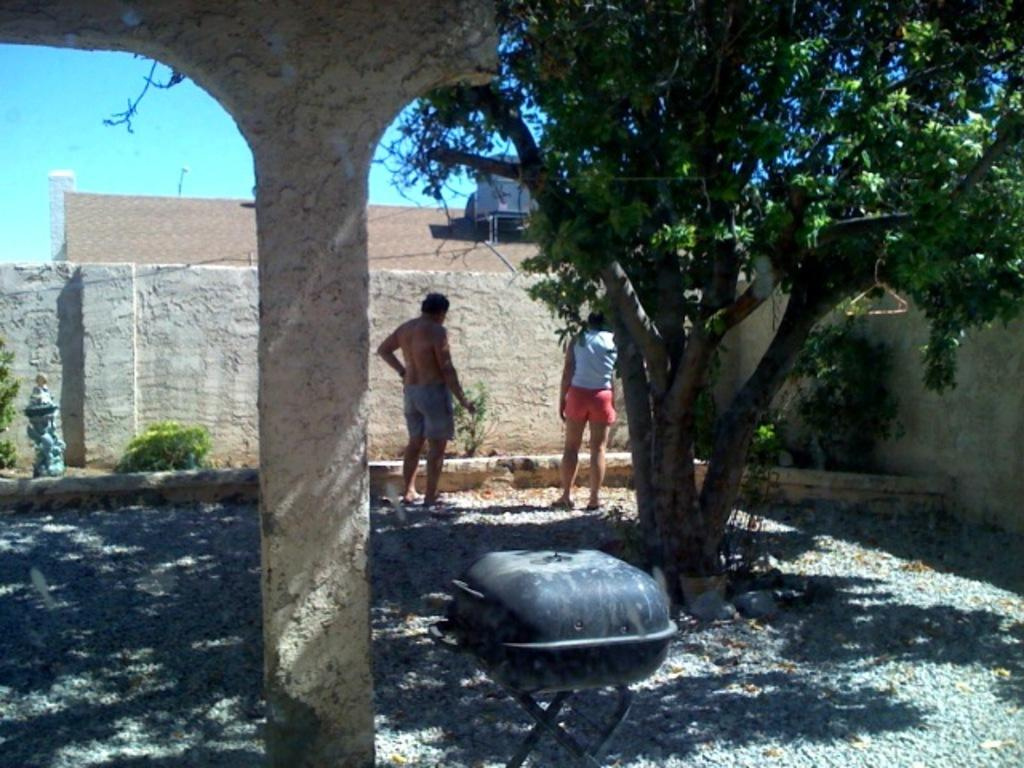How many people are present in the image? There are 2 people in the image. What is the setting of the image? The people are standing in a place with trees and plants. What can be seen in the image besides the people and plants? There is a grill stand in the image. Can you see a kite flying in the image? No, there is no kite visible in the image. 